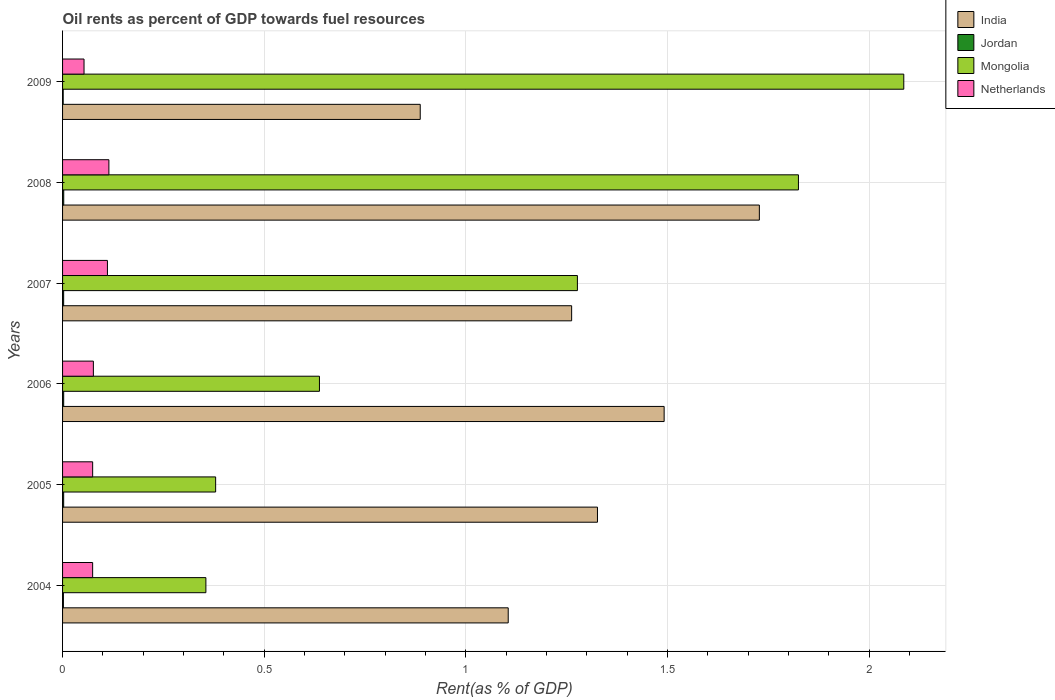Are the number of bars per tick equal to the number of legend labels?
Make the answer very short. Yes. In how many cases, is the number of bars for a given year not equal to the number of legend labels?
Your answer should be compact. 0. What is the oil rent in India in 2007?
Offer a very short reply. 1.26. Across all years, what is the maximum oil rent in Netherlands?
Keep it short and to the point. 0.11. Across all years, what is the minimum oil rent in Mongolia?
Your answer should be very brief. 0.36. In which year was the oil rent in Jordan maximum?
Your answer should be very brief. 2008. In which year was the oil rent in Jordan minimum?
Your answer should be compact. 2009. What is the total oil rent in Netherlands in the graph?
Keep it short and to the point. 0.5. What is the difference between the oil rent in India in 2004 and that in 2007?
Keep it short and to the point. -0.16. What is the difference between the oil rent in India in 2004 and the oil rent in Netherlands in 2007?
Your response must be concise. 0.99. What is the average oil rent in Netherlands per year?
Ensure brevity in your answer.  0.08. In the year 2005, what is the difference between the oil rent in India and oil rent in Netherlands?
Your answer should be compact. 1.25. What is the ratio of the oil rent in Jordan in 2007 to that in 2008?
Make the answer very short. 0.93. Is the difference between the oil rent in India in 2004 and 2007 greater than the difference between the oil rent in Netherlands in 2004 and 2007?
Offer a terse response. No. What is the difference between the highest and the second highest oil rent in India?
Make the answer very short. 0.24. What is the difference between the highest and the lowest oil rent in Mongolia?
Provide a succinct answer. 1.73. In how many years, is the oil rent in Netherlands greater than the average oil rent in Netherlands taken over all years?
Give a very brief answer. 2. Is the sum of the oil rent in Mongolia in 2005 and 2008 greater than the maximum oil rent in Netherlands across all years?
Your answer should be compact. Yes. What does the 4th bar from the top in 2007 represents?
Provide a short and direct response. India. How many bars are there?
Offer a very short reply. 24. Are all the bars in the graph horizontal?
Provide a succinct answer. Yes. What is the difference between two consecutive major ticks on the X-axis?
Provide a short and direct response. 0.5. Are the values on the major ticks of X-axis written in scientific E-notation?
Give a very brief answer. No. Does the graph contain any zero values?
Keep it short and to the point. No. Does the graph contain grids?
Offer a very short reply. Yes. Where does the legend appear in the graph?
Provide a succinct answer. Top right. What is the title of the graph?
Give a very brief answer. Oil rents as percent of GDP towards fuel resources. Does "Guinea-Bissau" appear as one of the legend labels in the graph?
Your answer should be compact. No. What is the label or title of the X-axis?
Provide a succinct answer. Rent(as % of GDP). What is the label or title of the Y-axis?
Provide a succinct answer. Years. What is the Rent(as % of GDP) in India in 2004?
Give a very brief answer. 1.1. What is the Rent(as % of GDP) in Jordan in 2004?
Your answer should be very brief. 0. What is the Rent(as % of GDP) of Mongolia in 2004?
Give a very brief answer. 0.36. What is the Rent(as % of GDP) in Netherlands in 2004?
Keep it short and to the point. 0.07. What is the Rent(as % of GDP) in India in 2005?
Offer a terse response. 1.33. What is the Rent(as % of GDP) in Jordan in 2005?
Offer a terse response. 0. What is the Rent(as % of GDP) of Mongolia in 2005?
Give a very brief answer. 0.38. What is the Rent(as % of GDP) of Netherlands in 2005?
Offer a very short reply. 0.07. What is the Rent(as % of GDP) in India in 2006?
Your response must be concise. 1.49. What is the Rent(as % of GDP) in Jordan in 2006?
Offer a terse response. 0. What is the Rent(as % of GDP) of Mongolia in 2006?
Offer a very short reply. 0.64. What is the Rent(as % of GDP) of Netherlands in 2006?
Give a very brief answer. 0.08. What is the Rent(as % of GDP) in India in 2007?
Offer a terse response. 1.26. What is the Rent(as % of GDP) of Jordan in 2007?
Ensure brevity in your answer.  0. What is the Rent(as % of GDP) in Mongolia in 2007?
Provide a short and direct response. 1.28. What is the Rent(as % of GDP) in Netherlands in 2007?
Give a very brief answer. 0.11. What is the Rent(as % of GDP) of India in 2008?
Keep it short and to the point. 1.73. What is the Rent(as % of GDP) in Jordan in 2008?
Make the answer very short. 0. What is the Rent(as % of GDP) in Mongolia in 2008?
Keep it short and to the point. 1.82. What is the Rent(as % of GDP) in Netherlands in 2008?
Your answer should be very brief. 0.11. What is the Rent(as % of GDP) in India in 2009?
Keep it short and to the point. 0.89. What is the Rent(as % of GDP) in Jordan in 2009?
Give a very brief answer. 0. What is the Rent(as % of GDP) of Mongolia in 2009?
Your answer should be very brief. 2.09. What is the Rent(as % of GDP) of Netherlands in 2009?
Make the answer very short. 0.05. Across all years, what is the maximum Rent(as % of GDP) of India?
Provide a short and direct response. 1.73. Across all years, what is the maximum Rent(as % of GDP) in Jordan?
Ensure brevity in your answer.  0. Across all years, what is the maximum Rent(as % of GDP) in Mongolia?
Offer a terse response. 2.09. Across all years, what is the maximum Rent(as % of GDP) of Netherlands?
Provide a succinct answer. 0.11. Across all years, what is the minimum Rent(as % of GDP) in India?
Your answer should be compact. 0.89. Across all years, what is the minimum Rent(as % of GDP) of Jordan?
Keep it short and to the point. 0. Across all years, what is the minimum Rent(as % of GDP) of Mongolia?
Provide a succinct answer. 0.36. Across all years, what is the minimum Rent(as % of GDP) of Netherlands?
Your response must be concise. 0.05. What is the total Rent(as % of GDP) of India in the graph?
Make the answer very short. 7.8. What is the total Rent(as % of GDP) in Jordan in the graph?
Ensure brevity in your answer.  0.01. What is the total Rent(as % of GDP) of Mongolia in the graph?
Provide a succinct answer. 6.56. What is the total Rent(as % of GDP) of Netherlands in the graph?
Make the answer very short. 0.5. What is the difference between the Rent(as % of GDP) in India in 2004 and that in 2005?
Offer a terse response. -0.22. What is the difference between the Rent(as % of GDP) of Jordan in 2004 and that in 2005?
Keep it short and to the point. -0. What is the difference between the Rent(as % of GDP) of Mongolia in 2004 and that in 2005?
Offer a terse response. -0.02. What is the difference between the Rent(as % of GDP) of Netherlands in 2004 and that in 2005?
Provide a short and direct response. -0. What is the difference between the Rent(as % of GDP) of India in 2004 and that in 2006?
Your answer should be compact. -0.39. What is the difference between the Rent(as % of GDP) of Jordan in 2004 and that in 2006?
Offer a terse response. -0. What is the difference between the Rent(as % of GDP) of Mongolia in 2004 and that in 2006?
Make the answer very short. -0.28. What is the difference between the Rent(as % of GDP) of Netherlands in 2004 and that in 2006?
Your answer should be very brief. -0. What is the difference between the Rent(as % of GDP) in India in 2004 and that in 2007?
Provide a short and direct response. -0.16. What is the difference between the Rent(as % of GDP) of Jordan in 2004 and that in 2007?
Provide a short and direct response. -0. What is the difference between the Rent(as % of GDP) in Mongolia in 2004 and that in 2007?
Offer a very short reply. -0.92. What is the difference between the Rent(as % of GDP) of Netherlands in 2004 and that in 2007?
Your response must be concise. -0.04. What is the difference between the Rent(as % of GDP) in India in 2004 and that in 2008?
Offer a very short reply. -0.62. What is the difference between the Rent(as % of GDP) in Jordan in 2004 and that in 2008?
Your answer should be very brief. -0. What is the difference between the Rent(as % of GDP) of Mongolia in 2004 and that in 2008?
Your answer should be compact. -1.47. What is the difference between the Rent(as % of GDP) in Netherlands in 2004 and that in 2008?
Ensure brevity in your answer.  -0.04. What is the difference between the Rent(as % of GDP) in India in 2004 and that in 2009?
Offer a very short reply. 0.22. What is the difference between the Rent(as % of GDP) of Mongolia in 2004 and that in 2009?
Offer a very short reply. -1.73. What is the difference between the Rent(as % of GDP) of Netherlands in 2004 and that in 2009?
Offer a terse response. 0.02. What is the difference between the Rent(as % of GDP) of India in 2005 and that in 2006?
Provide a succinct answer. -0.17. What is the difference between the Rent(as % of GDP) in Jordan in 2005 and that in 2006?
Provide a succinct answer. -0. What is the difference between the Rent(as % of GDP) in Mongolia in 2005 and that in 2006?
Your answer should be compact. -0.26. What is the difference between the Rent(as % of GDP) in Netherlands in 2005 and that in 2006?
Make the answer very short. -0. What is the difference between the Rent(as % of GDP) in India in 2005 and that in 2007?
Give a very brief answer. 0.06. What is the difference between the Rent(as % of GDP) of Jordan in 2005 and that in 2007?
Offer a terse response. 0. What is the difference between the Rent(as % of GDP) in Mongolia in 2005 and that in 2007?
Your answer should be compact. -0.9. What is the difference between the Rent(as % of GDP) of Netherlands in 2005 and that in 2007?
Provide a short and direct response. -0.04. What is the difference between the Rent(as % of GDP) in India in 2005 and that in 2008?
Offer a very short reply. -0.4. What is the difference between the Rent(as % of GDP) of Jordan in 2005 and that in 2008?
Ensure brevity in your answer.  -0. What is the difference between the Rent(as % of GDP) in Mongolia in 2005 and that in 2008?
Ensure brevity in your answer.  -1.44. What is the difference between the Rent(as % of GDP) in Netherlands in 2005 and that in 2008?
Keep it short and to the point. -0.04. What is the difference between the Rent(as % of GDP) in India in 2005 and that in 2009?
Your answer should be very brief. 0.44. What is the difference between the Rent(as % of GDP) in Jordan in 2005 and that in 2009?
Ensure brevity in your answer.  0. What is the difference between the Rent(as % of GDP) of Mongolia in 2005 and that in 2009?
Your response must be concise. -1.71. What is the difference between the Rent(as % of GDP) of Netherlands in 2005 and that in 2009?
Offer a terse response. 0.02. What is the difference between the Rent(as % of GDP) in India in 2006 and that in 2007?
Provide a succinct answer. 0.23. What is the difference between the Rent(as % of GDP) of Mongolia in 2006 and that in 2007?
Make the answer very short. -0.64. What is the difference between the Rent(as % of GDP) in Netherlands in 2006 and that in 2007?
Give a very brief answer. -0.03. What is the difference between the Rent(as % of GDP) in India in 2006 and that in 2008?
Your answer should be compact. -0.24. What is the difference between the Rent(as % of GDP) of Jordan in 2006 and that in 2008?
Keep it short and to the point. -0. What is the difference between the Rent(as % of GDP) in Mongolia in 2006 and that in 2008?
Your answer should be very brief. -1.19. What is the difference between the Rent(as % of GDP) in Netherlands in 2006 and that in 2008?
Provide a short and direct response. -0.04. What is the difference between the Rent(as % of GDP) of India in 2006 and that in 2009?
Make the answer very short. 0.6. What is the difference between the Rent(as % of GDP) in Jordan in 2006 and that in 2009?
Provide a short and direct response. 0. What is the difference between the Rent(as % of GDP) in Mongolia in 2006 and that in 2009?
Your answer should be compact. -1.45. What is the difference between the Rent(as % of GDP) in Netherlands in 2006 and that in 2009?
Provide a short and direct response. 0.02. What is the difference between the Rent(as % of GDP) of India in 2007 and that in 2008?
Provide a succinct answer. -0.47. What is the difference between the Rent(as % of GDP) of Jordan in 2007 and that in 2008?
Make the answer very short. -0. What is the difference between the Rent(as % of GDP) of Mongolia in 2007 and that in 2008?
Provide a succinct answer. -0.55. What is the difference between the Rent(as % of GDP) in Netherlands in 2007 and that in 2008?
Provide a short and direct response. -0. What is the difference between the Rent(as % of GDP) of India in 2007 and that in 2009?
Provide a succinct answer. 0.38. What is the difference between the Rent(as % of GDP) in Jordan in 2007 and that in 2009?
Provide a short and direct response. 0. What is the difference between the Rent(as % of GDP) in Mongolia in 2007 and that in 2009?
Provide a short and direct response. -0.81. What is the difference between the Rent(as % of GDP) in Netherlands in 2007 and that in 2009?
Provide a succinct answer. 0.06. What is the difference between the Rent(as % of GDP) of India in 2008 and that in 2009?
Offer a very short reply. 0.84. What is the difference between the Rent(as % of GDP) in Jordan in 2008 and that in 2009?
Your response must be concise. 0. What is the difference between the Rent(as % of GDP) in Mongolia in 2008 and that in 2009?
Your response must be concise. -0.26. What is the difference between the Rent(as % of GDP) of Netherlands in 2008 and that in 2009?
Your answer should be very brief. 0.06. What is the difference between the Rent(as % of GDP) of India in 2004 and the Rent(as % of GDP) of Jordan in 2005?
Offer a very short reply. 1.1. What is the difference between the Rent(as % of GDP) in India in 2004 and the Rent(as % of GDP) in Mongolia in 2005?
Offer a very short reply. 0.73. What is the difference between the Rent(as % of GDP) in India in 2004 and the Rent(as % of GDP) in Netherlands in 2005?
Your answer should be very brief. 1.03. What is the difference between the Rent(as % of GDP) of Jordan in 2004 and the Rent(as % of GDP) of Mongolia in 2005?
Your answer should be very brief. -0.38. What is the difference between the Rent(as % of GDP) in Jordan in 2004 and the Rent(as % of GDP) in Netherlands in 2005?
Give a very brief answer. -0.07. What is the difference between the Rent(as % of GDP) of Mongolia in 2004 and the Rent(as % of GDP) of Netherlands in 2005?
Give a very brief answer. 0.28. What is the difference between the Rent(as % of GDP) of India in 2004 and the Rent(as % of GDP) of Jordan in 2006?
Your answer should be compact. 1.1. What is the difference between the Rent(as % of GDP) in India in 2004 and the Rent(as % of GDP) in Mongolia in 2006?
Provide a short and direct response. 0.47. What is the difference between the Rent(as % of GDP) of India in 2004 and the Rent(as % of GDP) of Netherlands in 2006?
Provide a succinct answer. 1.03. What is the difference between the Rent(as % of GDP) in Jordan in 2004 and the Rent(as % of GDP) in Mongolia in 2006?
Your answer should be very brief. -0.63. What is the difference between the Rent(as % of GDP) of Jordan in 2004 and the Rent(as % of GDP) of Netherlands in 2006?
Provide a short and direct response. -0.07. What is the difference between the Rent(as % of GDP) of Mongolia in 2004 and the Rent(as % of GDP) of Netherlands in 2006?
Give a very brief answer. 0.28. What is the difference between the Rent(as % of GDP) in India in 2004 and the Rent(as % of GDP) in Jordan in 2007?
Keep it short and to the point. 1.1. What is the difference between the Rent(as % of GDP) of India in 2004 and the Rent(as % of GDP) of Mongolia in 2007?
Your answer should be very brief. -0.17. What is the difference between the Rent(as % of GDP) of Jordan in 2004 and the Rent(as % of GDP) of Mongolia in 2007?
Give a very brief answer. -1.27. What is the difference between the Rent(as % of GDP) in Jordan in 2004 and the Rent(as % of GDP) in Netherlands in 2007?
Offer a terse response. -0.11. What is the difference between the Rent(as % of GDP) in Mongolia in 2004 and the Rent(as % of GDP) in Netherlands in 2007?
Your answer should be compact. 0.24. What is the difference between the Rent(as % of GDP) in India in 2004 and the Rent(as % of GDP) in Jordan in 2008?
Give a very brief answer. 1.1. What is the difference between the Rent(as % of GDP) of India in 2004 and the Rent(as % of GDP) of Mongolia in 2008?
Offer a very short reply. -0.72. What is the difference between the Rent(as % of GDP) of India in 2004 and the Rent(as % of GDP) of Netherlands in 2008?
Offer a terse response. 0.99. What is the difference between the Rent(as % of GDP) of Jordan in 2004 and the Rent(as % of GDP) of Mongolia in 2008?
Your answer should be very brief. -1.82. What is the difference between the Rent(as % of GDP) in Jordan in 2004 and the Rent(as % of GDP) in Netherlands in 2008?
Your answer should be compact. -0.11. What is the difference between the Rent(as % of GDP) of Mongolia in 2004 and the Rent(as % of GDP) of Netherlands in 2008?
Provide a short and direct response. 0.24. What is the difference between the Rent(as % of GDP) of India in 2004 and the Rent(as % of GDP) of Jordan in 2009?
Give a very brief answer. 1.1. What is the difference between the Rent(as % of GDP) of India in 2004 and the Rent(as % of GDP) of Mongolia in 2009?
Keep it short and to the point. -0.98. What is the difference between the Rent(as % of GDP) of India in 2004 and the Rent(as % of GDP) of Netherlands in 2009?
Offer a terse response. 1.05. What is the difference between the Rent(as % of GDP) of Jordan in 2004 and the Rent(as % of GDP) of Mongolia in 2009?
Your answer should be compact. -2.08. What is the difference between the Rent(as % of GDP) in Jordan in 2004 and the Rent(as % of GDP) in Netherlands in 2009?
Your answer should be very brief. -0.05. What is the difference between the Rent(as % of GDP) of Mongolia in 2004 and the Rent(as % of GDP) of Netherlands in 2009?
Provide a short and direct response. 0.3. What is the difference between the Rent(as % of GDP) of India in 2005 and the Rent(as % of GDP) of Jordan in 2006?
Offer a very short reply. 1.32. What is the difference between the Rent(as % of GDP) in India in 2005 and the Rent(as % of GDP) in Mongolia in 2006?
Your answer should be compact. 0.69. What is the difference between the Rent(as % of GDP) in India in 2005 and the Rent(as % of GDP) in Netherlands in 2006?
Give a very brief answer. 1.25. What is the difference between the Rent(as % of GDP) of Jordan in 2005 and the Rent(as % of GDP) of Mongolia in 2006?
Offer a terse response. -0.63. What is the difference between the Rent(as % of GDP) in Jordan in 2005 and the Rent(as % of GDP) in Netherlands in 2006?
Ensure brevity in your answer.  -0.07. What is the difference between the Rent(as % of GDP) in Mongolia in 2005 and the Rent(as % of GDP) in Netherlands in 2006?
Your answer should be compact. 0.3. What is the difference between the Rent(as % of GDP) of India in 2005 and the Rent(as % of GDP) of Jordan in 2007?
Your answer should be compact. 1.32. What is the difference between the Rent(as % of GDP) of India in 2005 and the Rent(as % of GDP) of Mongolia in 2007?
Your response must be concise. 0.05. What is the difference between the Rent(as % of GDP) of India in 2005 and the Rent(as % of GDP) of Netherlands in 2007?
Keep it short and to the point. 1.21. What is the difference between the Rent(as % of GDP) in Jordan in 2005 and the Rent(as % of GDP) in Mongolia in 2007?
Keep it short and to the point. -1.27. What is the difference between the Rent(as % of GDP) in Jordan in 2005 and the Rent(as % of GDP) in Netherlands in 2007?
Give a very brief answer. -0.11. What is the difference between the Rent(as % of GDP) of Mongolia in 2005 and the Rent(as % of GDP) of Netherlands in 2007?
Offer a terse response. 0.27. What is the difference between the Rent(as % of GDP) in India in 2005 and the Rent(as % of GDP) in Jordan in 2008?
Your answer should be compact. 1.32. What is the difference between the Rent(as % of GDP) in India in 2005 and the Rent(as % of GDP) in Mongolia in 2008?
Offer a terse response. -0.5. What is the difference between the Rent(as % of GDP) in India in 2005 and the Rent(as % of GDP) in Netherlands in 2008?
Your response must be concise. 1.21. What is the difference between the Rent(as % of GDP) of Jordan in 2005 and the Rent(as % of GDP) of Mongolia in 2008?
Provide a short and direct response. -1.82. What is the difference between the Rent(as % of GDP) of Jordan in 2005 and the Rent(as % of GDP) of Netherlands in 2008?
Ensure brevity in your answer.  -0.11. What is the difference between the Rent(as % of GDP) of Mongolia in 2005 and the Rent(as % of GDP) of Netherlands in 2008?
Provide a short and direct response. 0.26. What is the difference between the Rent(as % of GDP) of India in 2005 and the Rent(as % of GDP) of Jordan in 2009?
Your answer should be compact. 1.32. What is the difference between the Rent(as % of GDP) of India in 2005 and the Rent(as % of GDP) of Mongolia in 2009?
Your response must be concise. -0.76. What is the difference between the Rent(as % of GDP) in India in 2005 and the Rent(as % of GDP) in Netherlands in 2009?
Offer a very short reply. 1.27. What is the difference between the Rent(as % of GDP) in Jordan in 2005 and the Rent(as % of GDP) in Mongolia in 2009?
Give a very brief answer. -2.08. What is the difference between the Rent(as % of GDP) of Jordan in 2005 and the Rent(as % of GDP) of Netherlands in 2009?
Ensure brevity in your answer.  -0.05. What is the difference between the Rent(as % of GDP) of Mongolia in 2005 and the Rent(as % of GDP) of Netherlands in 2009?
Your response must be concise. 0.33. What is the difference between the Rent(as % of GDP) of India in 2006 and the Rent(as % of GDP) of Jordan in 2007?
Ensure brevity in your answer.  1.49. What is the difference between the Rent(as % of GDP) of India in 2006 and the Rent(as % of GDP) of Mongolia in 2007?
Offer a very short reply. 0.21. What is the difference between the Rent(as % of GDP) of India in 2006 and the Rent(as % of GDP) of Netherlands in 2007?
Your answer should be compact. 1.38. What is the difference between the Rent(as % of GDP) in Jordan in 2006 and the Rent(as % of GDP) in Mongolia in 2007?
Keep it short and to the point. -1.27. What is the difference between the Rent(as % of GDP) of Jordan in 2006 and the Rent(as % of GDP) of Netherlands in 2007?
Ensure brevity in your answer.  -0.11. What is the difference between the Rent(as % of GDP) of Mongolia in 2006 and the Rent(as % of GDP) of Netherlands in 2007?
Offer a terse response. 0.53. What is the difference between the Rent(as % of GDP) of India in 2006 and the Rent(as % of GDP) of Jordan in 2008?
Your answer should be compact. 1.49. What is the difference between the Rent(as % of GDP) of India in 2006 and the Rent(as % of GDP) of Mongolia in 2008?
Provide a short and direct response. -0.33. What is the difference between the Rent(as % of GDP) of India in 2006 and the Rent(as % of GDP) of Netherlands in 2008?
Make the answer very short. 1.38. What is the difference between the Rent(as % of GDP) of Jordan in 2006 and the Rent(as % of GDP) of Mongolia in 2008?
Your response must be concise. -1.82. What is the difference between the Rent(as % of GDP) of Jordan in 2006 and the Rent(as % of GDP) of Netherlands in 2008?
Your answer should be compact. -0.11. What is the difference between the Rent(as % of GDP) in Mongolia in 2006 and the Rent(as % of GDP) in Netherlands in 2008?
Provide a short and direct response. 0.52. What is the difference between the Rent(as % of GDP) in India in 2006 and the Rent(as % of GDP) in Jordan in 2009?
Your response must be concise. 1.49. What is the difference between the Rent(as % of GDP) in India in 2006 and the Rent(as % of GDP) in Mongolia in 2009?
Offer a terse response. -0.59. What is the difference between the Rent(as % of GDP) in India in 2006 and the Rent(as % of GDP) in Netherlands in 2009?
Keep it short and to the point. 1.44. What is the difference between the Rent(as % of GDP) of Jordan in 2006 and the Rent(as % of GDP) of Mongolia in 2009?
Ensure brevity in your answer.  -2.08. What is the difference between the Rent(as % of GDP) in Jordan in 2006 and the Rent(as % of GDP) in Netherlands in 2009?
Ensure brevity in your answer.  -0.05. What is the difference between the Rent(as % of GDP) in Mongolia in 2006 and the Rent(as % of GDP) in Netherlands in 2009?
Your answer should be very brief. 0.58. What is the difference between the Rent(as % of GDP) in India in 2007 and the Rent(as % of GDP) in Jordan in 2008?
Give a very brief answer. 1.26. What is the difference between the Rent(as % of GDP) in India in 2007 and the Rent(as % of GDP) in Mongolia in 2008?
Make the answer very short. -0.56. What is the difference between the Rent(as % of GDP) in India in 2007 and the Rent(as % of GDP) in Netherlands in 2008?
Ensure brevity in your answer.  1.15. What is the difference between the Rent(as % of GDP) of Jordan in 2007 and the Rent(as % of GDP) of Mongolia in 2008?
Keep it short and to the point. -1.82. What is the difference between the Rent(as % of GDP) of Jordan in 2007 and the Rent(as % of GDP) of Netherlands in 2008?
Offer a very short reply. -0.11. What is the difference between the Rent(as % of GDP) of Mongolia in 2007 and the Rent(as % of GDP) of Netherlands in 2008?
Offer a terse response. 1.16. What is the difference between the Rent(as % of GDP) of India in 2007 and the Rent(as % of GDP) of Jordan in 2009?
Offer a terse response. 1.26. What is the difference between the Rent(as % of GDP) in India in 2007 and the Rent(as % of GDP) in Mongolia in 2009?
Your answer should be very brief. -0.82. What is the difference between the Rent(as % of GDP) of India in 2007 and the Rent(as % of GDP) of Netherlands in 2009?
Your response must be concise. 1.21. What is the difference between the Rent(as % of GDP) of Jordan in 2007 and the Rent(as % of GDP) of Mongolia in 2009?
Offer a terse response. -2.08. What is the difference between the Rent(as % of GDP) in Jordan in 2007 and the Rent(as % of GDP) in Netherlands in 2009?
Your answer should be compact. -0.05. What is the difference between the Rent(as % of GDP) in Mongolia in 2007 and the Rent(as % of GDP) in Netherlands in 2009?
Provide a succinct answer. 1.22. What is the difference between the Rent(as % of GDP) of India in 2008 and the Rent(as % of GDP) of Jordan in 2009?
Your answer should be very brief. 1.73. What is the difference between the Rent(as % of GDP) of India in 2008 and the Rent(as % of GDP) of Mongolia in 2009?
Make the answer very short. -0.36. What is the difference between the Rent(as % of GDP) of India in 2008 and the Rent(as % of GDP) of Netherlands in 2009?
Ensure brevity in your answer.  1.67. What is the difference between the Rent(as % of GDP) of Jordan in 2008 and the Rent(as % of GDP) of Mongolia in 2009?
Keep it short and to the point. -2.08. What is the difference between the Rent(as % of GDP) in Jordan in 2008 and the Rent(as % of GDP) in Netherlands in 2009?
Your answer should be very brief. -0.05. What is the difference between the Rent(as % of GDP) in Mongolia in 2008 and the Rent(as % of GDP) in Netherlands in 2009?
Your response must be concise. 1.77. What is the average Rent(as % of GDP) of India per year?
Keep it short and to the point. 1.3. What is the average Rent(as % of GDP) in Jordan per year?
Make the answer very short. 0. What is the average Rent(as % of GDP) in Mongolia per year?
Provide a short and direct response. 1.09. What is the average Rent(as % of GDP) of Netherlands per year?
Your answer should be compact. 0.08. In the year 2004, what is the difference between the Rent(as % of GDP) in India and Rent(as % of GDP) in Jordan?
Offer a very short reply. 1.1. In the year 2004, what is the difference between the Rent(as % of GDP) in India and Rent(as % of GDP) in Mongolia?
Provide a succinct answer. 0.75. In the year 2004, what is the difference between the Rent(as % of GDP) of India and Rent(as % of GDP) of Netherlands?
Offer a terse response. 1.03. In the year 2004, what is the difference between the Rent(as % of GDP) in Jordan and Rent(as % of GDP) in Mongolia?
Provide a short and direct response. -0.35. In the year 2004, what is the difference between the Rent(as % of GDP) in Jordan and Rent(as % of GDP) in Netherlands?
Keep it short and to the point. -0.07. In the year 2004, what is the difference between the Rent(as % of GDP) of Mongolia and Rent(as % of GDP) of Netherlands?
Make the answer very short. 0.28. In the year 2005, what is the difference between the Rent(as % of GDP) in India and Rent(as % of GDP) in Jordan?
Provide a succinct answer. 1.32. In the year 2005, what is the difference between the Rent(as % of GDP) in India and Rent(as % of GDP) in Mongolia?
Ensure brevity in your answer.  0.95. In the year 2005, what is the difference between the Rent(as % of GDP) of India and Rent(as % of GDP) of Netherlands?
Provide a short and direct response. 1.25. In the year 2005, what is the difference between the Rent(as % of GDP) in Jordan and Rent(as % of GDP) in Mongolia?
Provide a succinct answer. -0.38. In the year 2005, what is the difference between the Rent(as % of GDP) in Jordan and Rent(as % of GDP) in Netherlands?
Make the answer very short. -0.07. In the year 2005, what is the difference between the Rent(as % of GDP) of Mongolia and Rent(as % of GDP) of Netherlands?
Make the answer very short. 0.3. In the year 2006, what is the difference between the Rent(as % of GDP) of India and Rent(as % of GDP) of Jordan?
Offer a very short reply. 1.49. In the year 2006, what is the difference between the Rent(as % of GDP) in India and Rent(as % of GDP) in Mongolia?
Offer a very short reply. 0.85. In the year 2006, what is the difference between the Rent(as % of GDP) in India and Rent(as % of GDP) in Netherlands?
Your answer should be very brief. 1.42. In the year 2006, what is the difference between the Rent(as % of GDP) of Jordan and Rent(as % of GDP) of Mongolia?
Provide a short and direct response. -0.63. In the year 2006, what is the difference between the Rent(as % of GDP) of Jordan and Rent(as % of GDP) of Netherlands?
Your response must be concise. -0.07. In the year 2006, what is the difference between the Rent(as % of GDP) in Mongolia and Rent(as % of GDP) in Netherlands?
Your answer should be very brief. 0.56. In the year 2007, what is the difference between the Rent(as % of GDP) in India and Rent(as % of GDP) in Jordan?
Your answer should be very brief. 1.26. In the year 2007, what is the difference between the Rent(as % of GDP) in India and Rent(as % of GDP) in Mongolia?
Give a very brief answer. -0.01. In the year 2007, what is the difference between the Rent(as % of GDP) of India and Rent(as % of GDP) of Netherlands?
Your response must be concise. 1.15. In the year 2007, what is the difference between the Rent(as % of GDP) of Jordan and Rent(as % of GDP) of Mongolia?
Your answer should be compact. -1.27. In the year 2007, what is the difference between the Rent(as % of GDP) of Jordan and Rent(as % of GDP) of Netherlands?
Provide a succinct answer. -0.11. In the year 2007, what is the difference between the Rent(as % of GDP) of Mongolia and Rent(as % of GDP) of Netherlands?
Your answer should be compact. 1.17. In the year 2008, what is the difference between the Rent(as % of GDP) in India and Rent(as % of GDP) in Jordan?
Offer a very short reply. 1.72. In the year 2008, what is the difference between the Rent(as % of GDP) of India and Rent(as % of GDP) of Mongolia?
Keep it short and to the point. -0.1. In the year 2008, what is the difference between the Rent(as % of GDP) of India and Rent(as % of GDP) of Netherlands?
Your answer should be compact. 1.61. In the year 2008, what is the difference between the Rent(as % of GDP) in Jordan and Rent(as % of GDP) in Mongolia?
Your answer should be very brief. -1.82. In the year 2008, what is the difference between the Rent(as % of GDP) of Jordan and Rent(as % of GDP) of Netherlands?
Your response must be concise. -0.11. In the year 2008, what is the difference between the Rent(as % of GDP) of Mongolia and Rent(as % of GDP) of Netherlands?
Provide a succinct answer. 1.71. In the year 2009, what is the difference between the Rent(as % of GDP) in India and Rent(as % of GDP) in Jordan?
Your answer should be very brief. 0.89. In the year 2009, what is the difference between the Rent(as % of GDP) of India and Rent(as % of GDP) of Mongolia?
Make the answer very short. -1.2. In the year 2009, what is the difference between the Rent(as % of GDP) in India and Rent(as % of GDP) in Netherlands?
Ensure brevity in your answer.  0.83. In the year 2009, what is the difference between the Rent(as % of GDP) in Jordan and Rent(as % of GDP) in Mongolia?
Ensure brevity in your answer.  -2.08. In the year 2009, what is the difference between the Rent(as % of GDP) of Jordan and Rent(as % of GDP) of Netherlands?
Keep it short and to the point. -0.05. In the year 2009, what is the difference between the Rent(as % of GDP) in Mongolia and Rent(as % of GDP) in Netherlands?
Your answer should be compact. 2.03. What is the ratio of the Rent(as % of GDP) in India in 2004 to that in 2005?
Provide a succinct answer. 0.83. What is the ratio of the Rent(as % of GDP) of Jordan in 2004 to that in 2005?
Offer a terse response. 0.76. What is the ratio of the Rent(as % of GDP) of Mongolia in 2004 to that in 2005?
Your response must be concise. 0.94. What is the ratio of the Rent(as % of GDP) of Netherlands in 2004 to that in 2005?
Your response must be concise. 1. What is the ratio of the Rent(as % of GDP) in India in 2004 to that in 2006?
Ensure brevity in your answer.  0.74. What is the ratio of the Rent(as % of GDP) in Jordan in 2004 to that in 2006?
Keep it short and to the point. 0.75. What is the ratio of the Rent(as % of GDP) in Mongolia in 2004 to that in 2006?
Offer a very short reply. 0.56. What is the ratio of the Rent(as % of GDP) of Netherlands in 2004 to that in 2006?
Make the answer very short. 0.98. What is the ratio of the Rent(as % of GDP) in India in 2004 to that in 2007?
Offer a very short reply. 0.88. What is the ratio of the Rent(as % of GDP) of Jordan in 2004 to that in 2007?
Provide a short and direct response. 0.78. What is the ratio of the Rent(as % of GDP) in Mongolia in 2004 to that in 2007?
Offer a terse response. 0.28. What is the ratio of the Rent(as % of GDP) in Netherlands in 2004 to that in 2007?
Give a very brief answer. 0.67. What is the ratio of the Rent(as % of GDP) of India in 2004 to that in 2008?
Your answer should be compact. 0.64. What is the ratio of the Rent(as % of GDP) of Jordan in 2004 to that in 2008?
Provide a succinct answer. 0.72. What is the ratio of the Rent(as % of GDP) in Mongolia in 2004 to that in 2008?
Offer a very short reply. 0.19. What is the ratio of the Rent(as % of GDP) of Netherlands in 2004 to that in 2008?
Your response must be concise. 0.65. What is the ratio of the Rent(as % of GDP) of India in 2004 to that in 2009?
Keep it short and to the point. 1.25. What is the ratio of the Rent(as % of GDP) in Jordan in 2004 to that in 2009?
Offer a very short reply. 1.35. What is the ratio of the Rent(as % of GDP) in Mongolia in 2004 to that in 2009?
Offer a terse response. 0.17. What is the ratio of the Rent(as % of GDP) in Netherlands in 2004 to that in 2009?
Your answer should be very brief. 1.4. What is the ratio of the Rent(as % of GDP) of India in 2005 to that in 2006?
Keep it short and to the point. 0.89. What is the ratio of the Rent(as % of GDP) of Jordan in 2005 to that in 2006?
Your response must be concise. 0.99. What is the ratio of the Rent(as % of GDP) in Mongolia in 2005 to that in 2006?
Keep it short and to the point. 0.6. What is the ratio of the Rent(as % of GDP) of Netherlands in 2005 to that in 2006?
Offer a terse response. 0.98. What is the ratio of the Rent(as % of GDP) of India in 2005 to that in 2007?
Your response must be concise. 1.05. What is the ratio of the Rent(as % of GDP) in Jordan in 2005 to that in 2007?
Your answer should be very brief. 1.02. What is the ratio of the Rent(as % of GDP) of Mongolia in 2005 to that in 2007?
Ensure brevity in your answer.  0.3. What is the ratio of the Rent(as % of GDP) in Netherlands in 2005 to that in 2007?
Keep it short and to the point. 0.67. What is the ratio of the Rent(as % of GDP) in India in 2005 to that in 2008?
Your answer should be very brief. 0.77. What is the ratio of the Rent(as % of GDP) of Jordan in 2005 to that in 2008?
Keep it short and to the point. 0.95. What is the ratio of the Rent(as % of GDP) in Mongolia in 2005 to that in 2008?
Provide a succinct answer. 0.21. What is the ratio of the Rent(as % of GDP) in Netherlands in 2005 to that in 2008?
Provide a succinct answer. 0.65. What is the ratio of the Rent(as % of GDP) of India in 2005 to that in 2009?
Give a very brief answer. 1.5. What is the ratio of the Rent(as % of GDP) of Jordan in 2005 to that in 2009?
Offer a terse response. 1.78. What is the ratio of the Rent(as % of GDP) in Mongolia in 2005 to that in 2009?
Provide a short and direct response. 0.18. What is the ratio of the Rent(as % of GDP) in Netherlands in 2005 to that in 2009?
Provide a succinct answer. 1.4. What is the ratio of the Rent(as % of GDP) of India in 2006 to that in 2007?
Provide a short and direct response. 1.18. What is the ratio of the Rent(as % of GDP) of Jordan in 2006 to that in 2007?
Keep it short and to the point. 1.03. What is the ratio of the Rent(as % of GDP) of Mongolia in 2006 to that in 2007?
Ensure brevity in your answer.  0.5. What is the ratio of the Rent(as % of GDP) of Netherlands in 2006 to that in 2007?
Offer a very short reply. 0.69. What is the ratio of the Rent(as % of GDP) in India in 2006 to that in 2008?
Your response must be concise. 0.86. What is the ratio of the Rent(as % of GDP) in Jordan in 2006 to that in 2008?
Offer a terse response. 0.96. What is the ratio of the Rent(as % of GDP) in Mongolia in 2006 to that in 2008?
Your response must be concise. 0.35. What is the ratio of the Rent(as % of GDP) in Netherlands in 2006 to that in 2008?
Keep it short and to the point. 0.67. What is the ratio of the Rent(as % of GDP) in India in 2006 to that in 2009?
Give a very brief answer. 1.68. What is the ratio of the Rent(as % of GDP) in Jordan in 2006 to that in 2009?
Ensure brevity in your answer.  1.8. What is the ratio of the Rent(as % of GDP) in Mongolia in 2006 to that in 2009?
Provide a succinct answer. 0.31. What is the ratio of the Rent(as % of GDP) in Netherlands in 2006 to that in 2009?
Keep it short and to the point. 1.44. What is the ratio of the Rent(as % of GDP) of India in 2007 to that in 2008?
Make the answer very short. 0.73. What is the ratio of the Rent(as % of GDP) of Jordan in 2007 to that in 2008?
Ensure brevity in your answer.  0.93. What is the ratio of the Rent(as % of GDP) in Mongolia in 2007 to that in 2008?
Ensure brevity in your answer.  0.7. What is the ratio of the Rent(as % of GDP) of Netherlands in 2007 to that in 2008?
Offer a terse response. 0.97. What is the ratio of the Rent(as % of GDP) of India in 2007 to that in 2009?
Keep it short and to the point. 1.42. What is the ratio of the Rent(as % of GDP) of Jordan in 2007 to that in 2009?
Keep it short and to the point. 1.74. What is the ratio of the Rent(as % of GDP) of Mongolia in 2007 to that in 2009?
Keep it short and to the point. 0.61. What is the ratio of the Rent(as % of GDP) of Netherlands in 2007 to that in 2009?
Offer a terse response. 2.09. What is the ratio of the Rent(as % of GDP) in India in 2008 to that in 2009?
Offer a terse response. 1.95. What is the ratio of the Rent(as % of GDP) of Jordan in 2008 to that in 2009?
Your answer should be compact. 1.87. What is the ratio of the Rent(as % of GDP) in Mongolia in 2008 to that in 2009?
Provide a succinct answer. 0.87. What is the ratio of the Rent(as % of GDP) of Netherlands in 2008 to that in 2009?
Offer a terse response. 2.16. What is the difference between the highest and the second highest Rent(as % of GDP) in India?
Offer a terse response. 0.24. What is the difference between the highest and the second highest Rent(as % of GDP) in Mongolia?
Ensure brevity in your answer.  0.26. What is the difference between the highest and the second highest Rent(as % of GDP) of Netherlands?
Offer a very short reply. 0. What is the difference between the highest and the lowest Rent(as % of GDP) in India?
Provide a succinct answer. 0.84. What is the difference between the highest and the lowest Rent(as % of GDP) in Jordan?
Your response must be concise. 0. What is the difference between the highest and the lowest Rent(as % of GDP) in Mongolia?
Offer a terse response. 1.73. What is the difference between the highest and the lowest Rent(as % of GDP) in Netherlands?
Offer a very short reply. 0.06. 